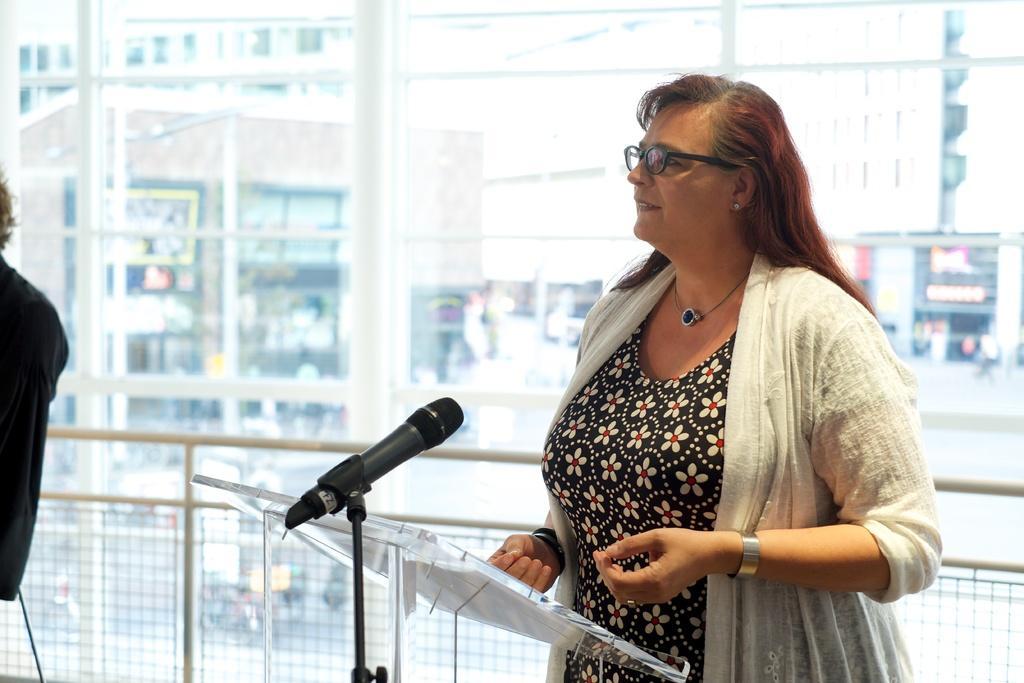Could you give a brief overview of what you see in this image? In this image I can see a woman is standing, I can see she is wearing white colour shrug, black dress and specs. I can also see a glass podium, a mic and here I can see one more person. In the background I can see few buildings and I can see this image is little bit blurry from background. 